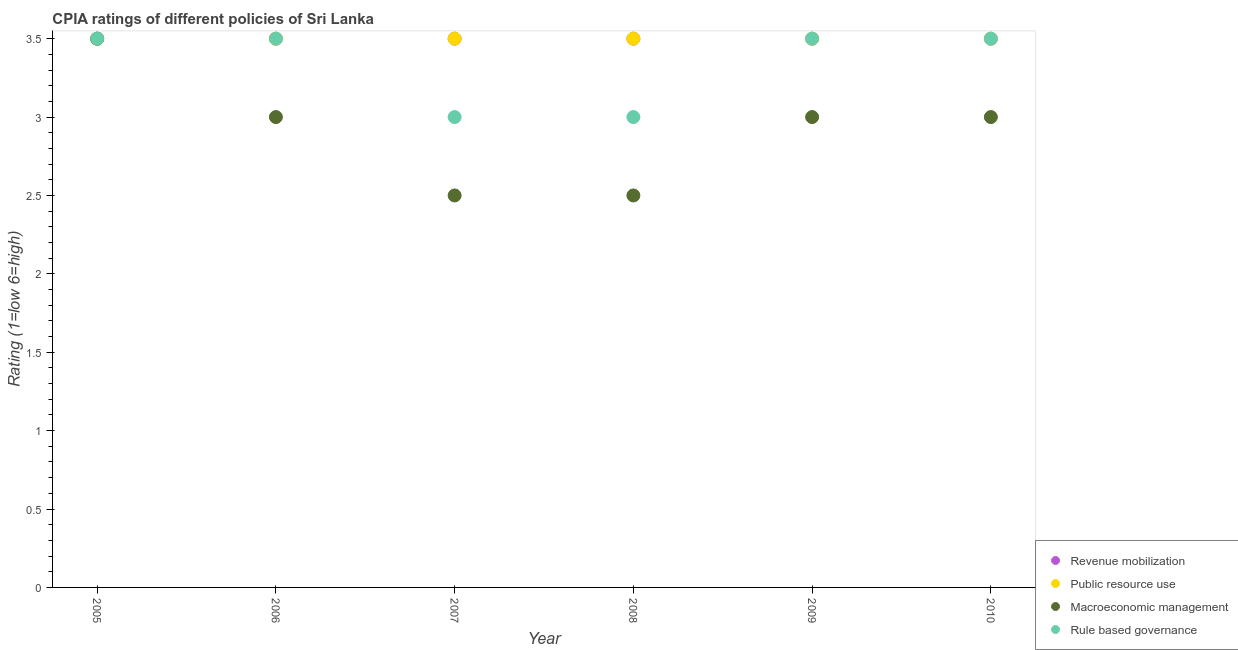In which year was the cpia rating of public resource use minimum?
Make the answer very short. 2005. What is the difference between the cpia rating of revenue mobilization in 2005 and that in 2007?
Give a very brief answer. 0. What is the average cpia rating of public resource use per year?
Offer a very short reply. 3.5. In the year 2008, what is the difference between the cpia rating of public resource use and cpia rating of macroeconomic management?
Your answer should be compact. 1. What is the ratio of the cpia rating of macroeconomic management in 2007 to that in 2008?
Your answer should be compact. 1. Is the difference between the cpia rating of public resource use in 2006 and 2008 greater than the difference between the cpia rating of rule based governance in 2006 and 2008?
Your response must be concise. No. What is the difference between the highest and the second highest cpia rating of rule based governance?
Offer a terse response. 0. What is the difference between the highest and the lowest cpia rating of macroeconomic management?
Keep it short and to the point. 1. In how many years, is the cpia rating of macroeconomic management greater than the average cpia rating of macroeconomic management taken over all years?
Provide a short and direct response. 4. Is it the case that in every year, the sum of the cpia rating of revenue mobilization and cpia rating of rule based governance is greater than the sum of cpia rating of public resource use and cpia rating of macroeconomic management?
Give a very brief answer. No. Is it the case that in every year, the sum of the cpia rating of revenue mobilization and cpia rating of public resource use is greater than the cpia rating of macroeconomic management?
Your answer should be very brief. Yes. Does the cpia rating of macroeconomic management monotonically increase over the years?
Offer a terse response. No. How many dotlines are there?
Offer a terse response. 4. What is the difference between two consecutive major ticks on the Y-axis?
Keep it short and to the point. 0.5. Where does the legend appear in the graph?
Your answer should be compact. Bottom right. What is the title of the graph?
Keep it short and to the point. CPIA ratings of different policies of Sri Lanka. What is the label or title of the X-axis?
Offer a terse response. Year. What is the Rating (1=low 6=high) in Revenue mobilization in 2006?
Your answer should be very brief. 3.5. What is the Rating (1=low 6=high) of Macroeconomic management in 2006?
Offer a terse response. 3. What is the Rating (1=low 6=high) in Rule based governance in 2006?
Provide a succinct answer. 3.5. What is the Rating (1=low 6=high) of Revenue mobilization in 2007?
Your response must be concise. 3.5. What is the Rating (1=low 6=high) of Macroeconomic management in 2007?
Give a very brief answer. 2.5. What is the Rating (1=low 6=high) of Revenue mobilization in 2008?
Ensure brevity in your answer.  3.5. What is the Rating (1=low 6=high) in Public resource use in 2008?
Make the answer very short. 3.5. What is the Rating (1=low 6=high) of Rule based governance in 2008?
Your response must be concise. 3. What is the Rating (1=low 6=high) of Revenue mobilization in 2009?
Offer a terse response. 3.5. What is the Rating (1=low 6=high) of Public resource use in 2009?
Offer a terse response. 3.5. What is the Rating (1=low 6=high) in Macroeconomic management in 2009?
Offer a very short reply. 3. What is the Rating (1=low 6=high) in Macroeconomic management in 2010?
Provide a succinct answer. 3. What is the Rating (1=low 6=high) of Rule based governance in 2010?
Ensure brevity in your answer.  3.5. Across all years, what is the maximum Rating (1=low 6=high) of Rule based governance?
Your answer should be very brief. 3.5. Across all years, what is the minimum Rating (1=low 6=high) in Public resource use?
Give a very brief answer. 3.5. What is the total Rating (1=low 6=high) in Revenue mobilization in the graph?
Make the answer very short. 21. What is the total Rating (1=low 6=high) of Public resource use in the graph?
Your answer should be compact. 21. What is the total Rating (1=low 6=high) in Rule based governance in the graph?
Your response must be concise. 20. What is the difference between the Rating (1=low 6=high) of Macroeconomic management in 2005 and that in 2006?
Provide a succinct answer. 0.5. What is the difference between the Rating (1=low 6=high) in Revenue mobilization in 2005 and that in 2007?
Provide a short and direct response. 0. What is the difference between the Rating (1=low 6=high) in Rule based governance in 2005 and that in 2007?
Provide a succinct answer. 0.5. What is the difference between the Rating (1=low 6=high) in Revenue mobilization in 2005 and that in 2008?
Ensure brevity in your answer.  0. What is the difference between the Rating (1=low 6=high) in Public resource use in 2005 and that in 2008?
Your answer should be very brief. 0. What is the difference between the Rating (1=low 6=high) of Macroeconomic management in 2005 and that in 2008?
Your answer should be very brief. 1. What is the difference between the Rating (1=low 6=high) of Revenue mobilization in 2005 and that in 2009?
Provide a succinct answer. 0. What is the difference between the Rating (1=low 6=high) in Public resource use in 2005 and that in 2009?
Ensure brevity in your answer.  0. What is the difference between the Rating (1=low 6=high) in Macroeconomic management in 2005 and that in 2009?
Make the answer very short. 0.5. What is the difference between the Rating (1=low 6=high) in Public resource use in 2005 and that in 2010?
Give a very brief answer. 0. What is the difference between the Rating (1=low 6=high) of Public resource use in 2006 and that in 2007?
Your response must be concise. 0. What is the difference between the Rating (1=low 6=high) in Macroeconomic management in 2006 and that in 2007?
Offer a terse response. 0.5. What is the difference between the Rating (1=low 6=high) of Rule based governance in 2006 and that in 2007?
Your response must be concise. 0.5. What is the difference between the Rating (1=low 6=high) in Public resource use in 2006 and that in 2008?
Keep it short and to the point. 0. What is the difference between the Rating (1=low 6=high) in Macroeconomic management in 2006 and that in 2008?
Provide a short and direct response. 0.5. What is the difference between the Rating (1=low 6=high) of Rule based governance in 2006 and that in 2008?
Offer a very short reply. 0.5. What is the difference between the Rating (1=low 6=high) of Revenue mobilization in 2006 and that in 2010?
Your answer should be very brief. 0. What is the difference between the Rating (1=low 6=high) of Public resource use in 2007 and that in 2008?
Ensure brevity in your answer.  0. What is the difference between the Rating (1=low 6=high) of Macroeconomic management in 2007 and that in 2008?
Offer a terse response. 0. What is the difference between the Rating (1=low 6=high) of Public resource use in 2007 and that in 2009?
Your response must be concise. 0. What is the difference between the Rating (1=low 6=high) of Revenue mobilization in 2007 and that in 2010?
Ensure brevity in your answer.  0. What is the difference between the Rating (1=low 6=high) in Public resource use in 2007 and that in 2010?
Offer a very short reply. 0. What is the difference between the Rating (1=low 6=high) in Macroeconomic management in 2007 and that in 2010?
Keep it short and to the point. -0.5. What is the difference between the Rating (1=low 6=high) of Revenue mobilization in 2008 and that in 2009?
Ensure brevity in your answer.  0. What is the difference between the Rating (1=low 6=high) in Public resource use in 2008 and that in 2009?
Provide a succinct answer. 0. What is the difference between the Rating (1=low 6=high) in Macroeconomic management in 2008 and that in 2009?
Offer a terse response. -0.5. What is the difference between the Rating (1=low 6=high) of Revenue mobilization in 2008 and that in 2010?
Provide a succinct answer. 0. What is the difference between the Rating (1=low 6=high) in Macroeconomic management in 2008 and that in 2010?
Provide a short and direct response. -0.5. What is the difference between the Rating (1=low 6=high) in Rule based governance in 2008 and that in 2010?
Provide a succinct answer. -0.5. What is the difference between the Rating (1=low 6=high) in Revenue mobilization in 2009 and that in 2010?
Provide a short and direct response. 0. What is the difference between the Rating (1=low 6=high) of Macroeconomic management in 2009 and that in 2010?
Offer a terse response. 0. What is the difference between the Rating (1=low 6=high) of Rule based governance in 2009 and that in 2010?
Provide a short and direct response. 0. What is the difference between the Rating (1=low 6=high) in Revenue mobilization in 2005 and the Rating (1=low 6=high) in Public resource use in 2006?
Provide a short and direct response. 0. What is the difference between the Rating (1=low 6=high) of Public resource use in 2005 and the Rating (1=low 6=high) of Macroeconomic management in 2006?
Provide a succinct answer. 0.5. What is the difference between the Rating (1=low 6=high) in Public resource use in 2005 and the Rating (1=low 6=high) in Rule based governance in 2006?
Keep it short and to the point. 0. What is the difference between the Rating (1=low 6=high) of Macroeconomic management in 2005 and the Rating (1=low 6=high) of Rule based governance in 2006?
Offer a terse response. 0. What is the difference between the Rating (1=low 6=high) of Revenue mobilization in 2005 and the Rating (1=low 6=high) of Public resource use in 2007?
Provide a succinct answer. 0. What is the difference between the Rating (1=low 6=high) in Revenue mobilization in 2005 and the Rating (1=low 6=high) in Macroeconomic management in 2007?
Keep it short and to the point. 1. What is the difference between the Rating (1=low 6=high) of Public resource use in 2005 and the Rating (1=low 6=high) of Rule based governance in 2007?
Offer a terse response. 0.5. What is the difference between the Rating (1=low 6=high) of Revenue mobilization in 2005 and the Rating (1=low 6=high) of Macroeconomic management in 2008?
Make the answer very short. 1. What is the difference between the Rating (1=low 6=high) in Revenue mobilization in 2005 and the Rating (1=low 6=high) in Rule based governance in 2008?
Give a very brief answer. 0.5. What is the difference between the Rating (1=low 6=high) in Public resource use in 2005 and the Rating (1=low 6=high) in Macroeconomic management in 2008?
Offer a terse response. 1. What is the difference between the Rating (1=low 6=high) in Public resource use in 2005 and the Rating (1=low 6=high) in Rule based governance in 2008?
Offer a very short reply. 0.5. What is the difference between the Rating (1=low 6=high) in Macroeconomic management in 2005 and the Rating (1=low 6=high) in Rule based governance in 2008?
Provide a short and direct response. 0.5. What is the difference between the Rating (1=low 6=high) in Revenue mobilization in 2005 and the Rating (1=low 6=high) in Macroeconomic management in 2009?
Provide a succinct answer. 0.5. What is the difference between the Rating (1=low 6=high) in Public resource use in 2005 and the Rating (1=low 6=high) in Macroeconomic management in 2009?
Offer a very short reply. 0.5. What is the difference between the Rating (1=low 6=high) of Public resource use in 2005 and the Rating (1=low 6=high) of Rule based governance in 2009?
Provide a short and direct response. 0. What is the difference between the Rating (1=low 6=high) in Revenue mobilization in 2005 and the Rating (1=low 6=high) in Macroeconomic management in 2010?
Give a very brief answer. 0.5. What is the difference between the Rating (1=low 6=high) of Revenue mobilization in 2005 and the Rating (1=low 6=high) of Rule based governance in 2010?
Provide a short and direct response. 0. What is the difference between the Rating (1=low 6=high) in Public resource use in 2005 and the Rating (1=low 6=high) in Rule based governance in 2010?
Your answer should be compact. 0. What is the difference between the Rating (1=low 6=high) in Macroeconomic management in 2005 and the Rating (1=low 6=high) in Rule based governance in 2010?
Your answer should be compact. 0. What is the difference between the Rating (1=low 6=high) of Revenue mobilization in 2006 and the Rating (1=low 6=high) of Macroeconomic management in 2007?
Your answer should be very brief. 1. What is the difference between the Rating (1=low 6=high) of Revenue mobilization in 2006 and the Rating (1=low 6=high) of Rule based governance in 2007?
Give a very brief answer. 0.5. What is the difference between the Rating (1=low 6=high) in Revenue mobilization in 2006 and the Rating (1=low 6=high) in Public resource use in 2008?
Ensure brevity in your answer.  0. What is the difference between the Rating (1=low 6=high) of Revenue mobilization in 2006 and the Rating (1=low 6=high) of Rule based governance in 2008?
Provide a short and direct response. 0.5. What is the difference between the Rating (1=low 6=high) in Public resource use in 2006 and the Rating (1=low 6=high) in Macroeconomic management in 2008?
Offer a terse response. 1. What is the difference between the Rating (1=low 6=high) in Macroeconomic management in 2006 and the Rating (1=low 6=high) in Rule based governance in 2008?
Provide a succinct answer. 0. What is the difference between the Rating (1=low 6=high) of Revenue mobilization in 2006 and the Rating (1=low 6=high) of Rule based governance in 2009?
Your answer should be very brief. 0. What is the difference between the Rating (1=low 6=high) in Public resource use in 2006 and the Rating (1=low 6=high) in Macroeconomic management in 2009?
Offer a very short reply. 0.5. What is the difference between the Rating (1=low 6=high) in Macroeconomic management in 2006 and the Rating (1=low 6=high) in Rule based governance in 2009?
Provide a short and direct response. -0.5. What is the difference between the Rating (1=low 6=high) in Revenue mobilization in 2006 and the Rating (1=low 6=high) in Public resource use in 2010?
Provide a short and direct response. 0. What is the difference between the Rating (1=low 6=high) in Revenue mobilization in 2006 and the Rating (1=low 6=high) in Rule based governance in 2010?
Provide a short and direct response. 0. What is the difference between the Rating (1=low 6=high) in Public resource use in 2006 and the Rating (1=low 6=high) in Rule based governance in 2010?
Provide a short and direct response. 0. What is the difference between the Rating (1=low 6=high) of Revenue mobilization in 2007 and the Rating (1=low 6=high) of Public resource use in 2008?
Your answer should be very brief. 0. What is the difference between the Rating (1=low 6=high) in Revenue mobilization in 2007 and the Rating (1=low 6=high) in Rule based governance in 2008?
Provide a succinct answer. 0.5. What is the difference between the Rating (1=low 6=high) in Public resource use in 2007 and the Rating (1=low 6=high) in Macroeconomic management in 2008?
Provide a succinct answer. 1. What is the difference between the Rating (1=low 6=high) in Public resource use in 2007 and the Rating (1=low 6=high) in Rule based governance in 2008?
Your response must be concise. 0.5. What is the difference between the Rating (1=low 6=high) in Public resource use in 2007 and the Rating (1=low 6=high) in Macroeconomic management in 2009?
Provide a succinct answer. 0.5. What is the difference between the Rating (1=low 6=high) of Public resource use in 2007 and the Rating (1=low 6=high) of Rule based governance in 2009?
Ensure brevity in your answer.  0. What is the difference between the Rating (1=low 6=high) of Revenue mobilization in 2007 and the Rating (1=low 6=high) of Macroeconomic management in 2010?
Your answer should be very brief. 0.5. What is the difference between the Rating (1=low 6=high) in Revenue mobilization in 2007 and the Rating (1=low 6=high) in Rule based governance in 2010?
Your response must be concise. 0. What is the difference between the Rating (1=low 6=high) in Public resource use in 2007 and the Rating (1=low 6=high) in Rule based governance in 2010?
Provide a short and direct response. 0. What is the difference between the Rating (1=low 6=high) of Public resource use in 2008 and the Rating (1=low 6=high) of Rule based governance in 2009?
Your answer should be compact. 0. What is the difference between the Rating (1=low 6=high) in Public resource use in 2008 and the Rating (1=low 6=high) in Macroeconomic management in 2010?
Offer a very short reply. 0.5. What is the difference between the Rating (1=low 6=high) in Public resource use in 2008 and the Rating (1=low 6=high) in Rule based governance in 2010?
Provide a succinct answer. 0. What is the difference between the Rating (1=low 6=high) of Revenue mobilization in 2009 and the Rating (1=low 6=high) of Public resource use in 2010?
Offer a very short reply. 0. What is the difference between the Rating (1=low 6=high) in Public resource use in 2009 and the Rating (1=low 6=high) in Rule based governance in 2010?
Offer a very short reply. 0. What is the difference between the Rating (1=low 6=high) of Macroeconomic management in 2009 and the Rating (1=low 6=high) of Rule based governance in 2010?
Make the answer very short. -0.5. What is the average Rating (1=low 6=high) in Revenue mobilization per year?
Keep it short and to the point. 3.5. What is the average Rating (1=low 6=high) in Macroeconomic management per year?
Keep it short and to the point. 2.92. What is the average Rating (1=low 6=high) of Rule based governance per year?
Provide a short and direct response. 3.33. In the year 2005, what is the difference between the Rating (1=low 6=high) in Macroeconomic management and Rating (1=low 6=high) in Rule based governance?
Your answer should be compact. 0. In the year 2006, what is the difference between the Rating (1=low 6=high) in Revenue mobilization and Rating (1=low 6=high) in Rule based governance?
Make the answer very short. 0. In the year 2006, what is the difference between the Rating (1=low 6=high) of Public resource use and Rating (1=low 6=high) of Macroeconomic management?
Give a very brief answer. 0.5. In the year 2006, what is the difference between the Rating (1=low 6=high) of Public resource use and Rating (1=low 6=high) of Rule based governance?
Your answer should be compact. 0. In the year 2006, what is the difference between the Rating (1=low 6=high) of Macroeconomic management and Rating (1=low 6=high) of Rule based governance?
Keep it short and to the point. -0.5. In the year 2007, what is the difference between the Rating (1=low 6=high) in Revenue mobilization and Rating (1=low 6=high) in Public resource use?
Keep it short and to the point. 0. In the year 2007, what is the difference between the Rating (1=low 6=high) in Revenue mobilization and Rating (1=low 6=high) in Macroeconomic management?
Your answer should be very brief. 1. In the year 2007, what is the difference between the Rating (1=low 6=high) of Revenue mobilization and Rating (1=low 6=high) of Rule based governance?
Give a very brief answer. 0.5. In the year 2007, what is the difference between the Rating (1=low 6=high) in Public resource use and Rating (1=low 6=high) in Macroeconomic management?
Provide a short and direct response. 1. In the year 2007, what is the difference between the Rating (1=low 6=high) in Public resource use and Rating (1=low 6=high) in Rule based governance?
Your response must be concise. 0.5. In the year 2008, what is the difference between the Rating (1=low 6=high) in Revenue mobilization and Rating (1=low 6=high) in Public resource use?
Your answer should be very brief. 0. In the year 2008, what is the difference between the Rating (1=low 6=high) in Revenue mobilization and Rating (1=low 6=high) in Macroeconomic management?
Provide a succinct answer. 1. In the year 2008, what is the difference between the Rating (1=low 6=high) in Public resource use and Rating (1=low 6=high) in Rule based governance?
Provide a short and direct response. 0.5. In the year 2008, what is the difference between the Rating (1=low 6=high) in Macroeconomic management and Rating (1=low 6=high) in Rule based governance?
Make the answer very short. -0.5. In the year 2009, what is the difference between the Rating (1=low 6=high) in Revenue mobilization and Rating (1=low 6=high) in Public resource use?
Offer a terse response. 0. In the year 2009, what is the difference between the Rating (1=low 6=high) of Revenue mobilization and Rating (1=low 6=high) of Macroeconomic management?
Offer a terse response. 0.5. In the year 2009, what is the difference between the Rating (1=low 6=high) of Revenue mobilization and Rating (1=low 6=high) of Rule based governance?
Your answer should be very brief. 0. In the year 2009, what is the difference between the Rating (1=low 6=high) in Public resource use and Rating (1=low 6=high) in Macroeconomic management?
Your response must be concise. 0.5. In the year 2009, what is the difference between the Rating (1=low 6=high) in Public resource use and Rating (1=low 6=high) in Rule based governance?
Your answer should be compact. 0. In the year 2009, what is the difference between the Rating (1=low 6=high) of Macroeconomic management and Rating (1=low 6=high) of Rule based governance?
Offer a terse response. -0.5. In the year 2010, what is the difference between the Rating (1=low 6=high) of Revenue mobilization and Rating (1=low 6=high) of Public resource use?
Keep it short and to the point. 0. In the year 2010, what is the difference between the Rating (1=low 6=high) in Revenue mobilization and Rating (1=low 6=high) in Macroeconomic management?
Give a very brief answer. 0.5. What is the ratio of the Rating (1=low 6=high) in Public resource use in 2005 to that in 2006?
Ensure brevity in your answer.  1. What is the ratio of the Rating (1=low 6=high) in Macroeconomic management in 2005 to that in 2008?
Offer a very short reply. 1.4. What is the ratio of the Rating (1=low 6=high) in Rule based governance in 2005 to that in 2008?
Your answer should be compact. 1.17. What is the ratio of the Rating (1=low 6=high) of Revenue mobilization in 2005 to that in 2009?
Offer a very short reply. 1. What is the ratio of the Rating (1=low 6=high) in Macroeconomic management in 2005 to that in 2009?
Offer a terse response. 1.17. What is the ratio of the Rating (1=low 6=high) in Rule based governance in 2005 to that in 2009?
Provide a succinct answer. 1. What is the ratio of the Rating (1=low 6=high) of Macroeconomic management in 2005 to that in 2010?
Provide a succinct answer. 1.17. What is the ratio of the Rating (1=low 6=high) in Rule based governance in 2005 to that in 2010?
Make the answer very short. 1. What is the ratio of the Rating (1=low 6=high) of Public resource use in 2006 to that in 2007?
Your response must be concise. 1. What is the ratio of the Rating (1=low 6=high) of Revenue mobilization in 2006 to that in 2008?
Ensure brevity in your answer.  1. What is the ratio of the Rating (1=low 6=high) of Rule based governance in 2006 to that in 2008?
Your answer should be compact. 1.17. What is the ratio of the Rating (1=low 6=high) of Macroeconomic management in 2006 to that in 2009?
Your answer should be compact. 1. What is the ratio of the Rating (1=low 6=high) in Rule based governance in 2006 to that in 2009?
Your answer should be compact. 1. What is the ratio of the Rating (1=low 6=high) in Revenue mobilization in 2006 to that in 2010?
Ensure brevity in your answer.  1. What is the ratio of the Rating (1=low 6=high) in Rule based governance in 2006 to that in 2010?
Ensure brevity in your answer.  1. What is the ratio of the Rating (1=low 6=high) of Revenue mobilization in 2007 to that in 2008?
Ensure brevity in your answer.  1. What is the ratio of the Rating (1=low 6=high) of Macroeconomic management in 2007 to that in 2008?
Offer a terse response. 1. What is the ratio of the Rating (1=low 6=high) of Rule based governance in 2007 to that in 2008?
Your response must be concise. 1. What is the ratio of the Rating (1=low 6=high) of Public resource use in 2007 to that in 2009?
Offer a terse response. 1. What is the ratio of the Rating (1=low 6=high) of Macroeconomic management in 2007 to that in 2009?
Provide a short and direct response. 0.83. What is the ratio of the Rating (1=low 6=high) in Rule based governance in 2007 to that in 2009?
Keep it short and to the point. 0.86. What is the ratio of the Rating (1=low 6=high) in Public resource use in 2007 to that in 2010?
Give a very brief answer. 1. What is the ratio of the Rating (1=low 6=high) of Rule based governance in 2007 to that in 2010?
Ensure brevity in your answer.  0.86. What is the ratio of the Rating (1=low 6=high) in Revenue mobilization in 2008 to that in 2009?
Make the answer very short. 1. What is the ratio of the Rating (1=low 6=high) in Macroeconomic management in 2008 to that in 2009?
Provide a succinct answer. 0.83. What is the ratio of the Rating (1=low 6=high) of Rule based governance in 2008 to that in 2009?
Keep it short and to the point. 0.86. What is the ratio of the Rating (1=low 6=high) of Revenue mobilization in 2008 to that in 2010?
Provide a succinct answer. 1. What is the ratio of the Rating (1=low 6=high) of Rule based governance in 2008 to that in 2010?
Your answer should be compact. 0.86. What is the difference between the highest and the second highest Rating (1=low 6=high) of Macroeconomic management?
Provide a short and direct response. 0.5. What is the difference between the highest and the lowest Rating (1=low 6=high) in Revenue mobilization?
Keep it short and to the point. 0. 